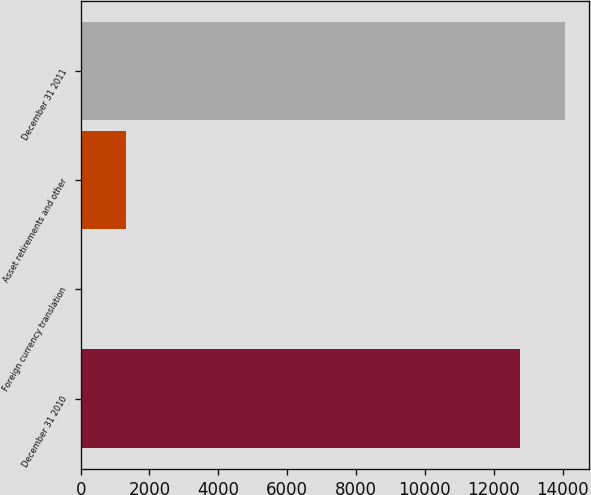Convert chart to OTSL. <chart><loc_0><loc_0><loc_500><loc_500><bar_chart><fcel>December 31 2010<fcel>Foreign currency translation<fcel>Asset retirements and other<fcel>December 31 2011<nl><fcel>12777<fcel>32<fcel>1322.8<fcel>14067.8<nl></chart> 